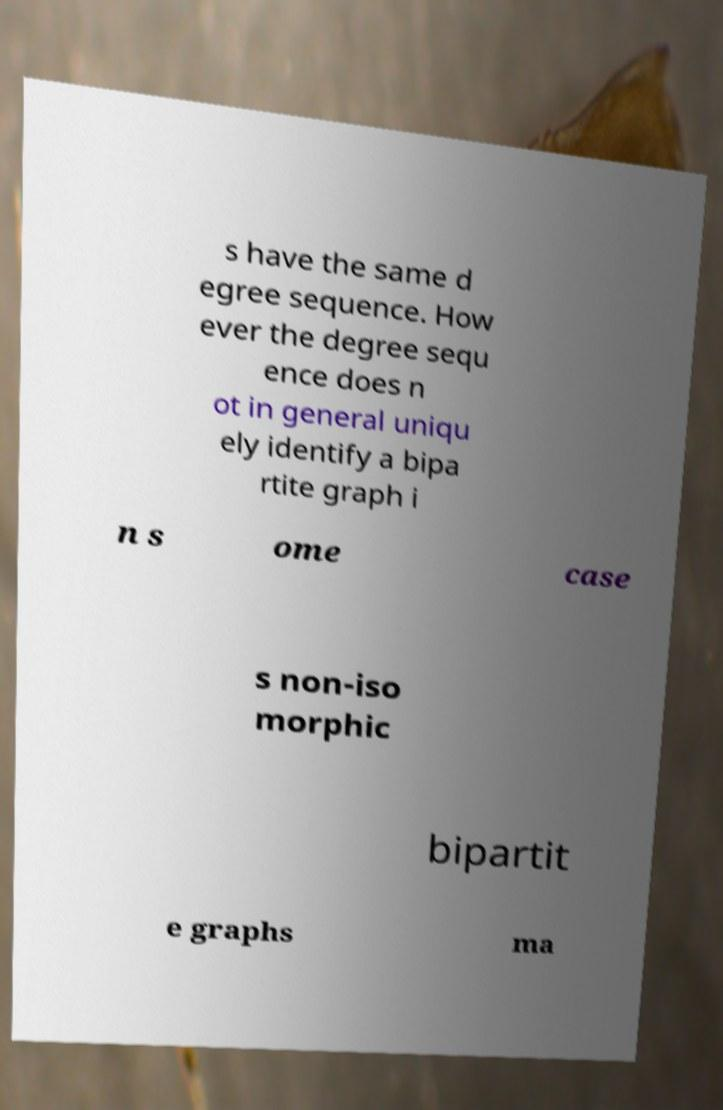Could you assist in decoding the text presented in this image and type it out clearly? s have the same d egree sequence. How ever the degree sequ ence does n ot in general uniqu ely identify a bipa rtite graph i n s ome case s non-iso morphic bipartit e graphs ma 